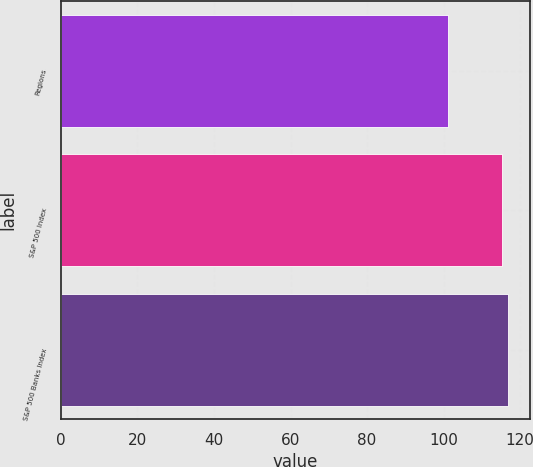Convert chart. <chart><loc_0><loc_0><loc_500><loc_500><bar_chart><fcel>Regions<fcel>S&P 500 Index<fcel>S&P 500 Banks Index<nl><fcel>101.11<fcel>115.24<fcel>116.78<nl></chart> 